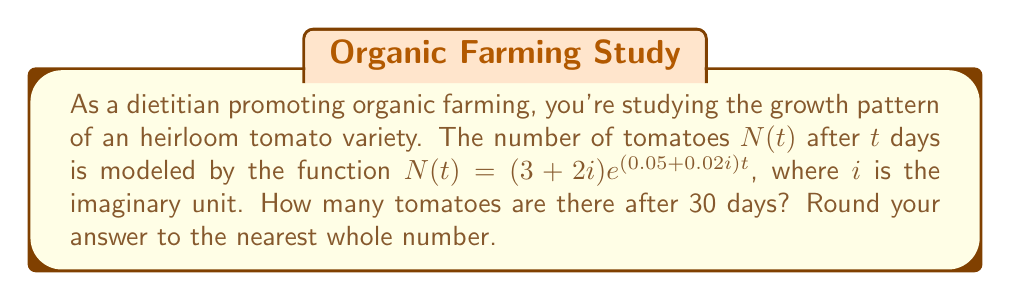Could you help me with this problem? To solve this problem, we'll follow these steps:

1) We have the function $N(t) = (3+2i)e^{(0.05+0.02i)t}$
   We need to find $N(30)$

2) Substitute $t=30$ into the function:
   $N(30) = (3+2i)e^{(0.05+0.02i)(30)}$

3) Simplify the exponent:
   $N(30) = (3+2i)e^{1.5+0.6i}$

4) We can write this in polar form:
   $e^{1.5+0.6i} = e^{1.5}(\cos(0.6) + i\sin(0.6))$

5) Multiply this by $(3+2i)$:
   $N(30) = (3+2i)e^{1.5}(\cos(0.6) + i\sin(0.6))$

6) Expand:
   $N(30) = (3e^{1.5}\cos(0.6) - 2e^{1.5}\sin(0.6)) + (2e^{1.5}\cos(0.6) + 3e^{1.5}\sin(0.6))i$

7) Calculate the magnitude:
   $|N(30)| = \sqrt{(3e^{1.5}\cos(0.6) - 2e^{1.5}\sin(0.6))^2 + (2e^{1.5}\cos(0.6) + 3e^{1.5}\sin(0.6))^2}$

8) Using a calculator:
   $|N(30)| \approx 13.4$

9) Rounding to the nearest whole number:
   $|N(30)| \approx 13$
Answer: 13 tomatoes 